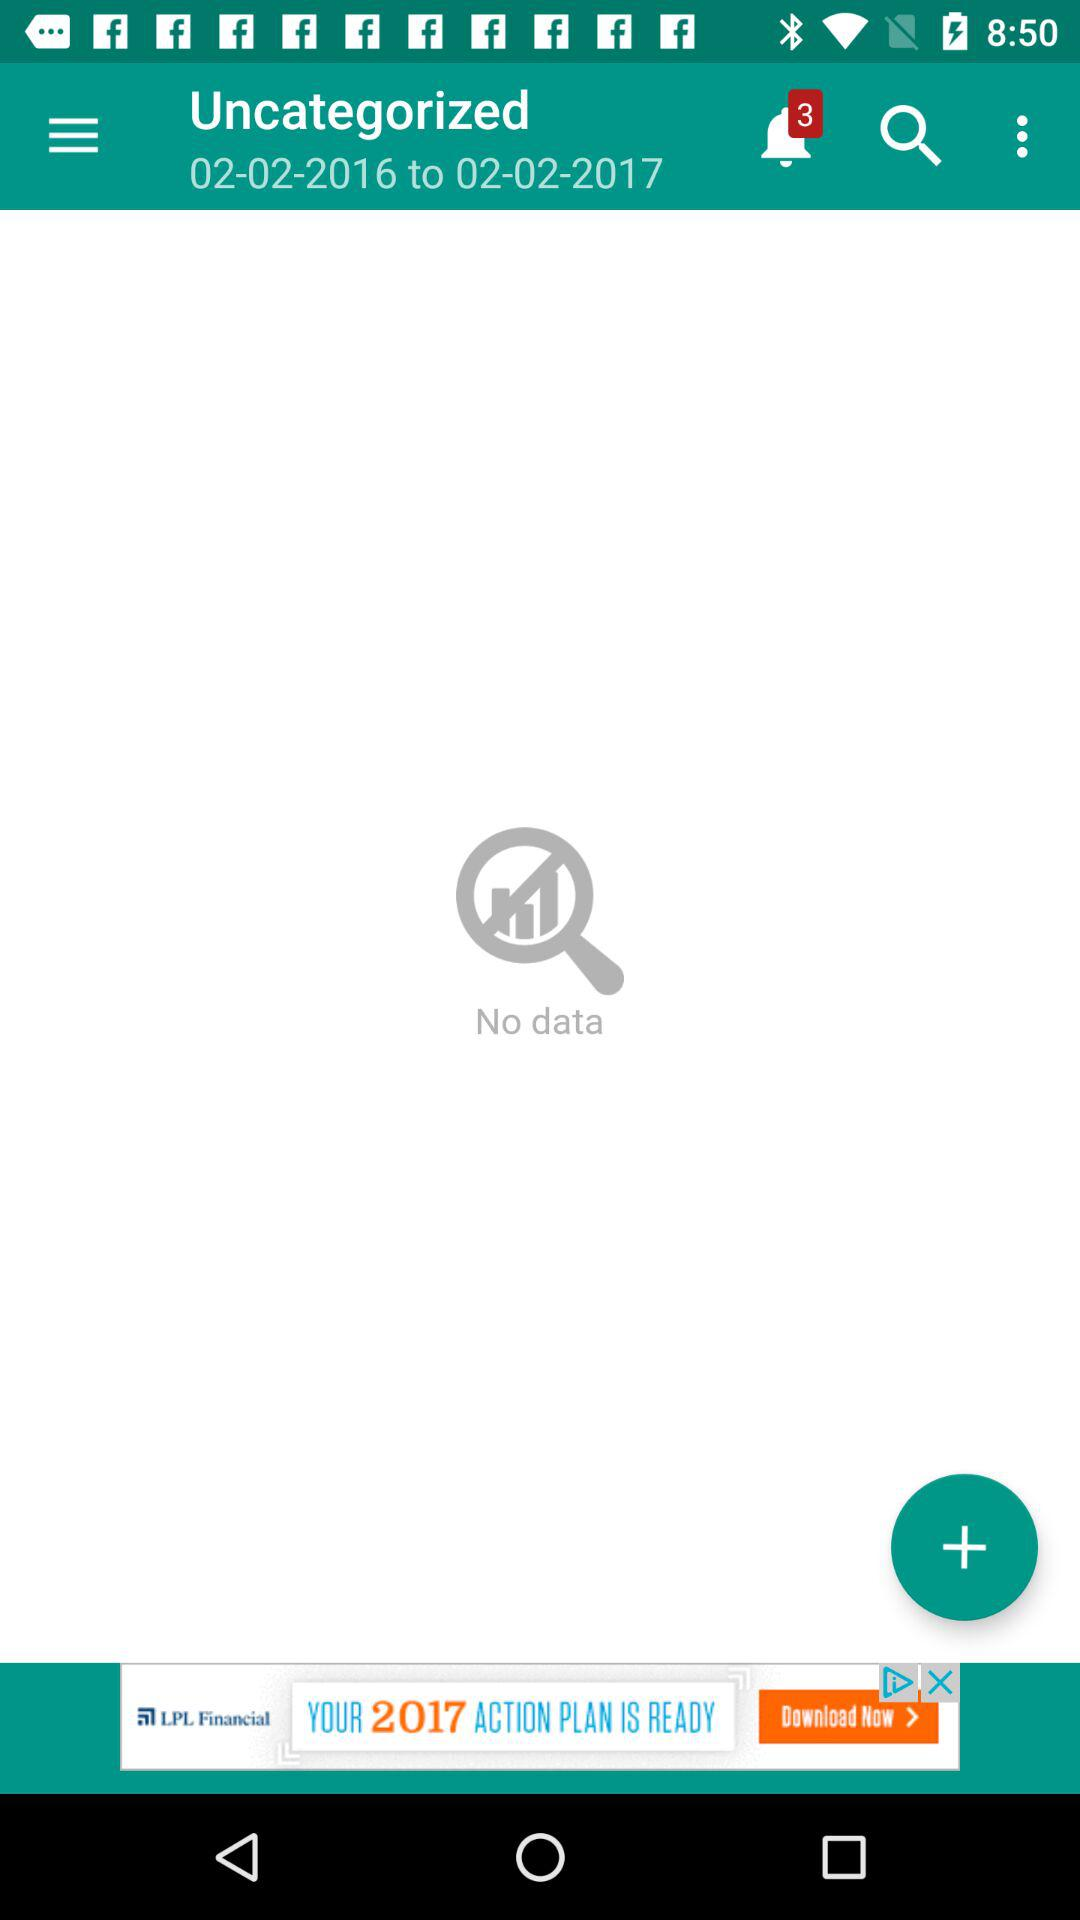How many notifications are there? There are 3 notifications. 